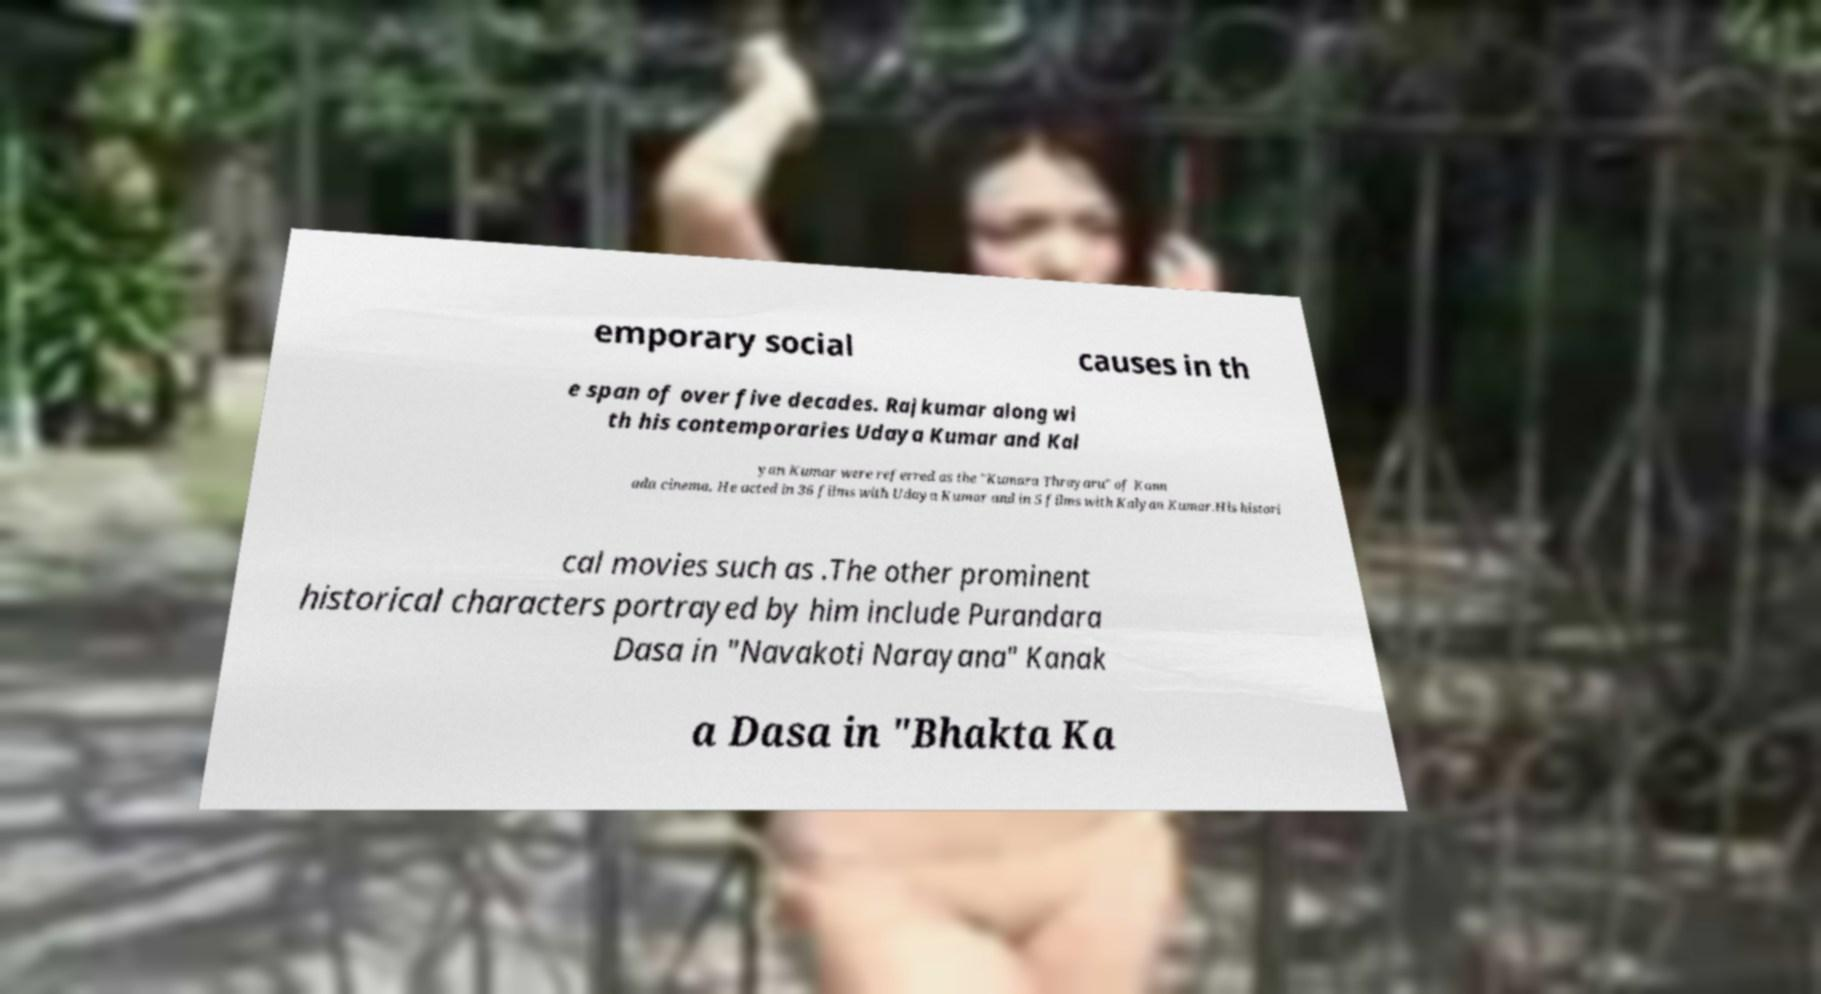Please read and relay the text visible in this image. What does it say? emporary social causes in th e span of over five decades. Rajkumar along wi th his contemporaries Udaya Kumar and Kal yan Kumar were referred as the "Kumara Thrayaru" of Kann ada cinema. He acted in 36 films with Udaya Kumar and in 5 films with Kalyan Kumar.His histori cal movies such as .The other prominent historical characters portrayed by him include Purandara Dasa in "Navakoti Narayana" Kanak a Dasa in "Bhakta Ka 